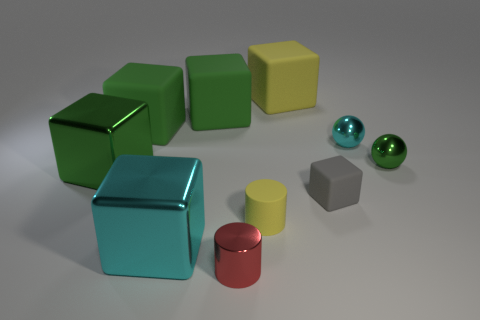Subtract all cyan balls. How many green blocks are left? 3 Subtract 2 cubes. How many cubes are left? 4 Subtract all gray cubes. How many cubes are left? 5 Subtract all large cyan blocks. How many blocks are left? 5 Subtract all gray blocks. Subtract all purple spheres. How many blocks are left? 5 Subtract all cylinders. How many objects are left? 8 Subtract 0 brown cylinders. How many objects are left? 10 Subtract all green shiny cubes. Subtract all green blocks. How many objects are left? 6 Add 1 metal blocks. How many metal blocks are left? 3 Add 7 tiny green balls. How many tiny green balls exist? 8 